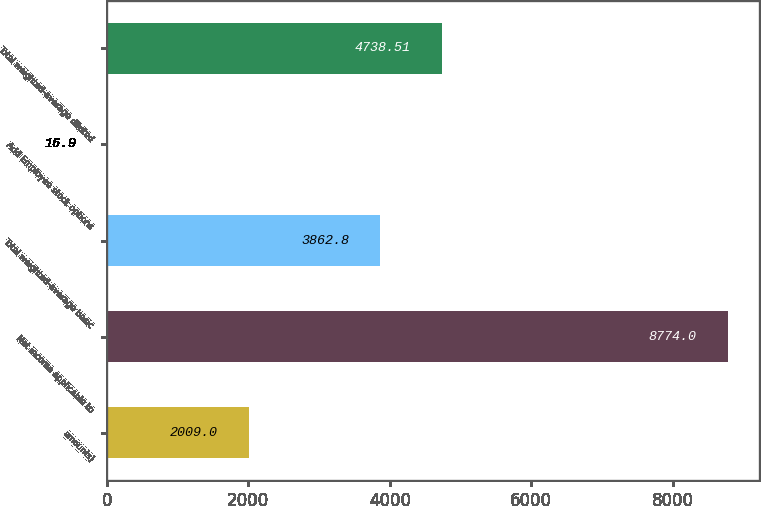<chart> <loc_0><loc_0><loc_500><loc_500><bar_chart><fcel>amounts)<fcel>Net income applicable to<fcel>Total weighted-average basic<fcel>Add Employee stock options<fcel>Total weighted-average diluted<nl><fcel>2009<fcel>8774<fcel>3862.8<fcel>16.9<fcel>4738.51<nl></chart> 